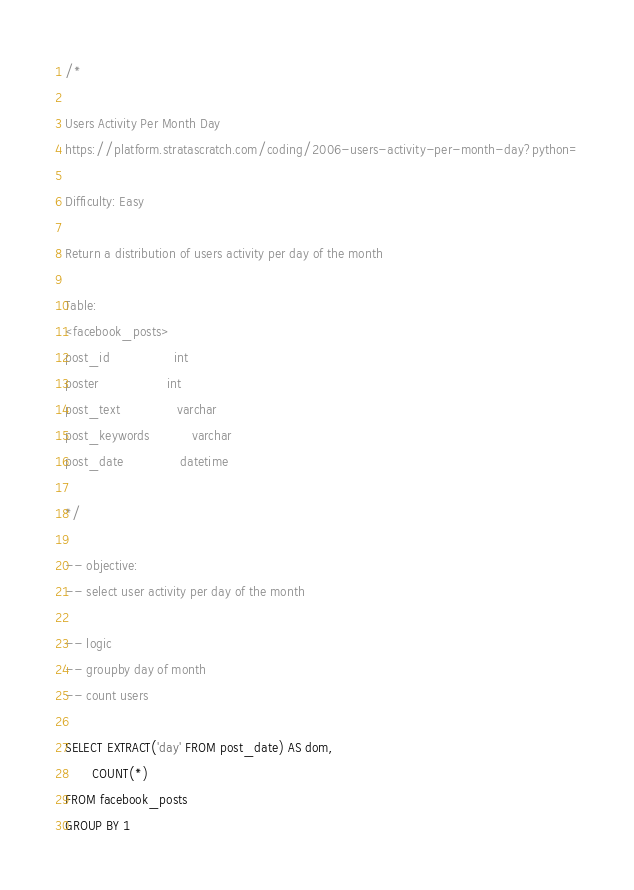Convert code to text. <code><loc_0><loc_0><loc_500><loc_500><_SQL_>/*

Users Activity Per Month Day
https://platform.stratascratch.com/coding/2006-users-activity-per-month-day?python=

Difficulty: Easy

Return a distribution of users activity per day of the month

Table:
<facebook_posts>
post_id                 int
poster                  int
post_text               varchar
post_keywords           varchar
post_date               datetime

*/

-- objective:
-- select user activity per day of the month

-- logic
-- groupby day of month
-- count users

SELECT EXTRACT('day' FROM post_date) AS dom,
       COUNT(*)
FROM facebook_posts
GROUP BY 1
</code> 